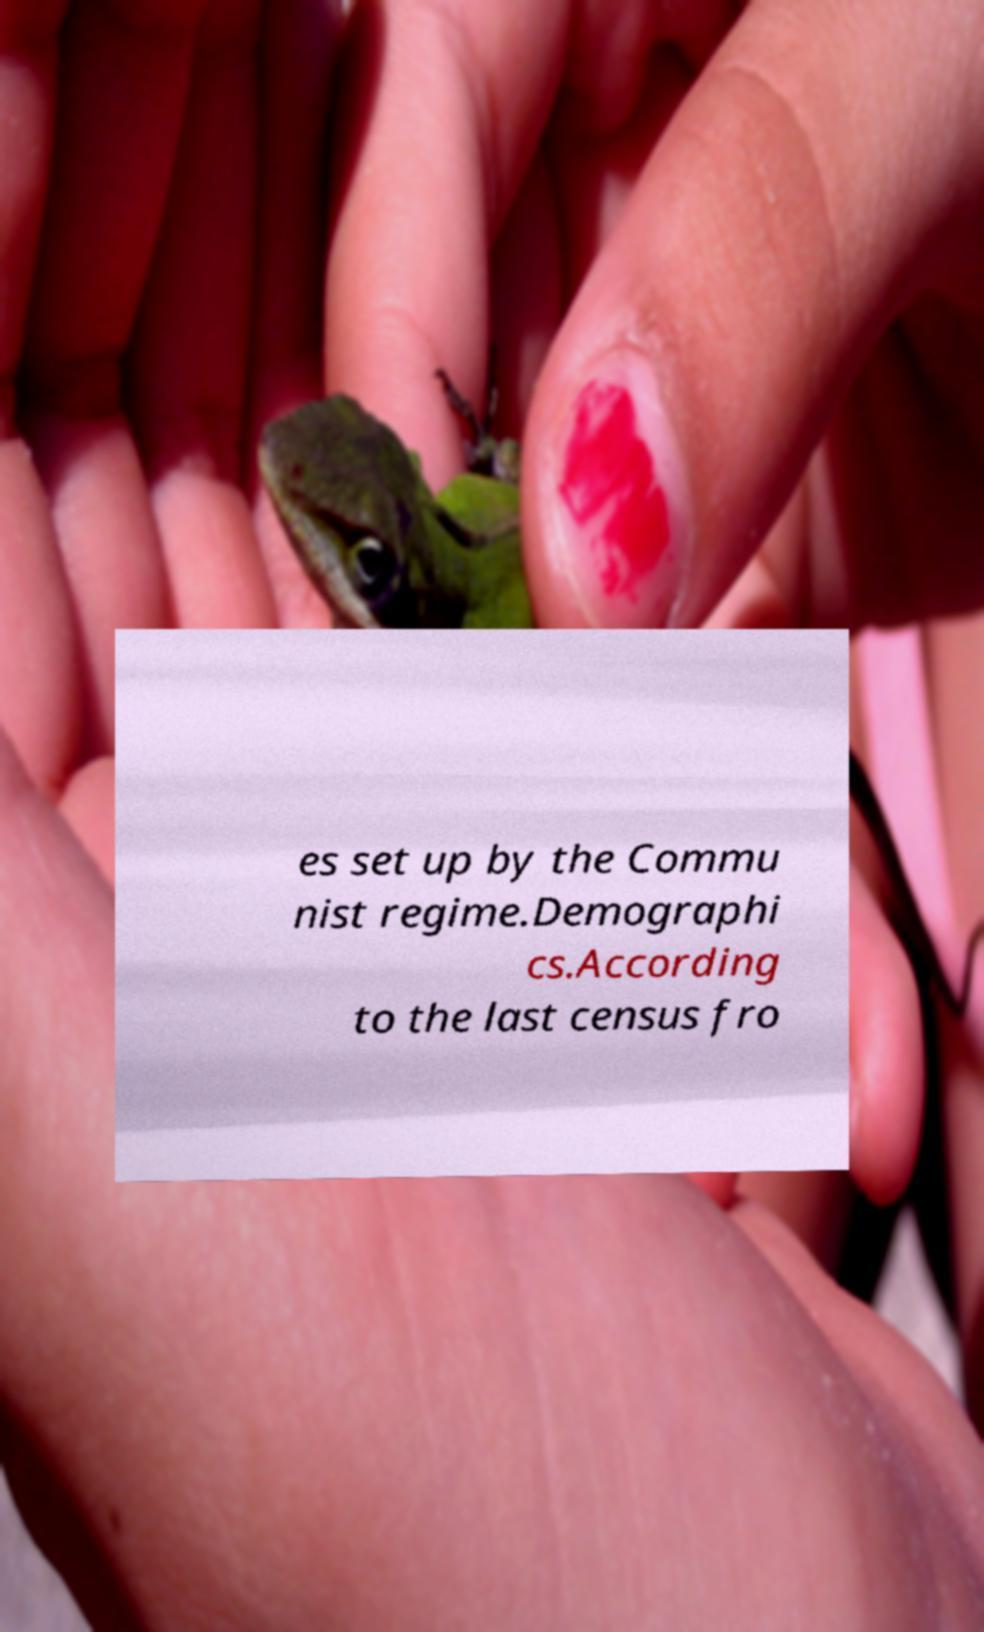Could you assist in decoding the text presented in this image and type it out clearly? es set up by the Commu nist regime.Demographi cs.According to the last census fro 